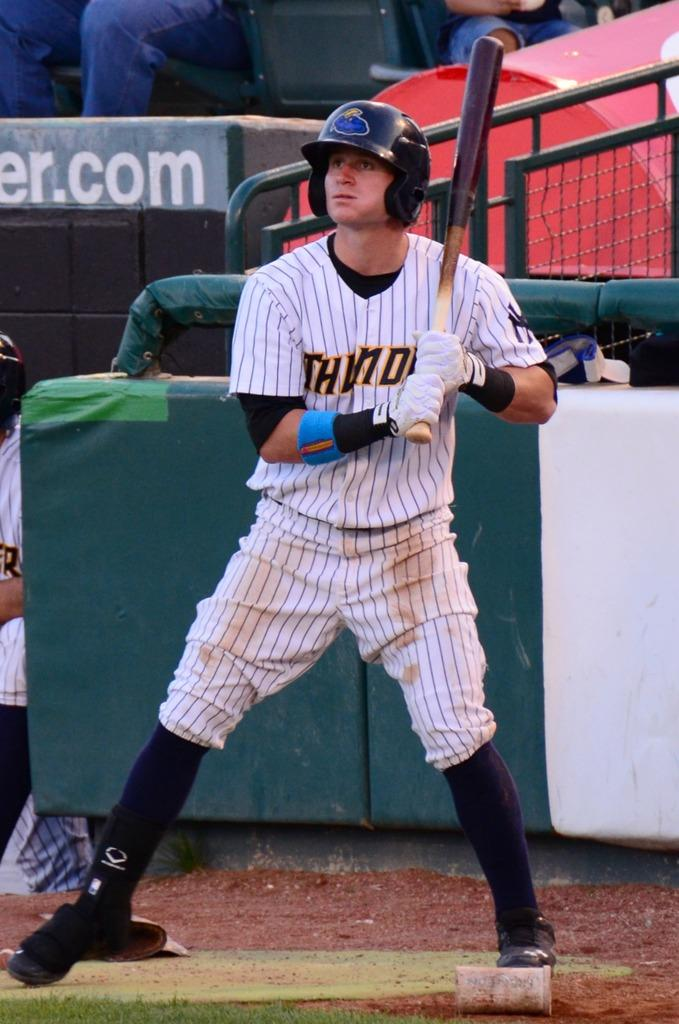<image>
Give a short and clear explanation of the subsequent image. Baseball player waiting on deck watching the game holding a baseball bat and wearing a jersey that says Thunder. 